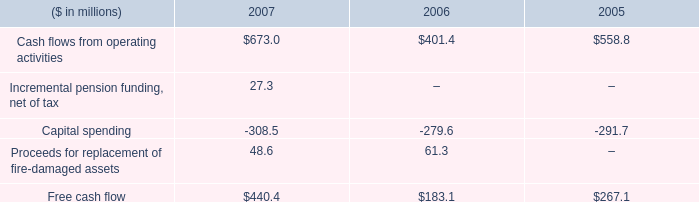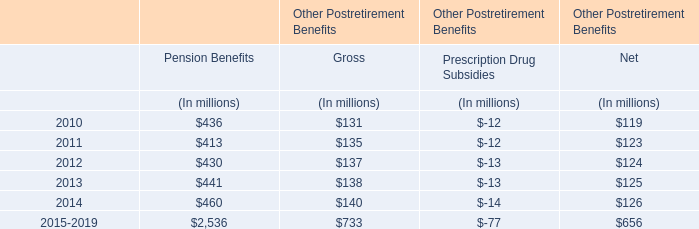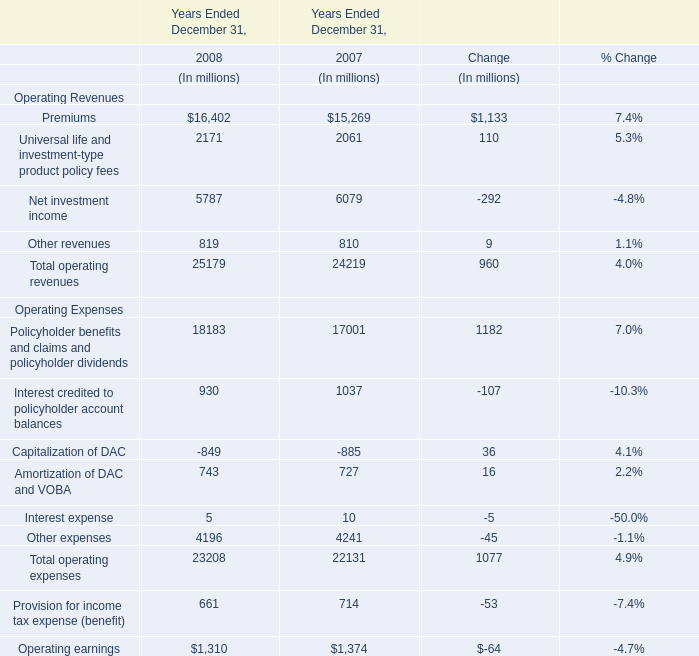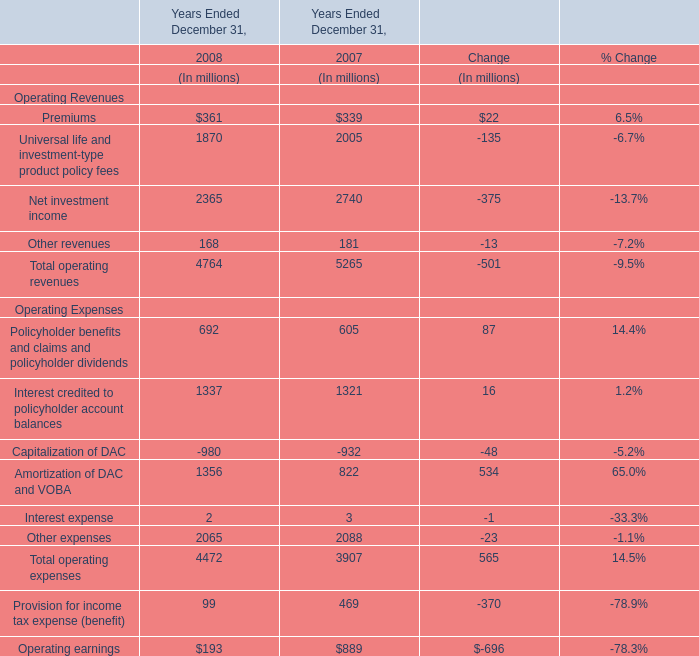what is the percentage change in capital spending from 2006 to 2007? 
Computations: ((308.5 - 279.6) / 279.6)
Answer: 0.10336. 